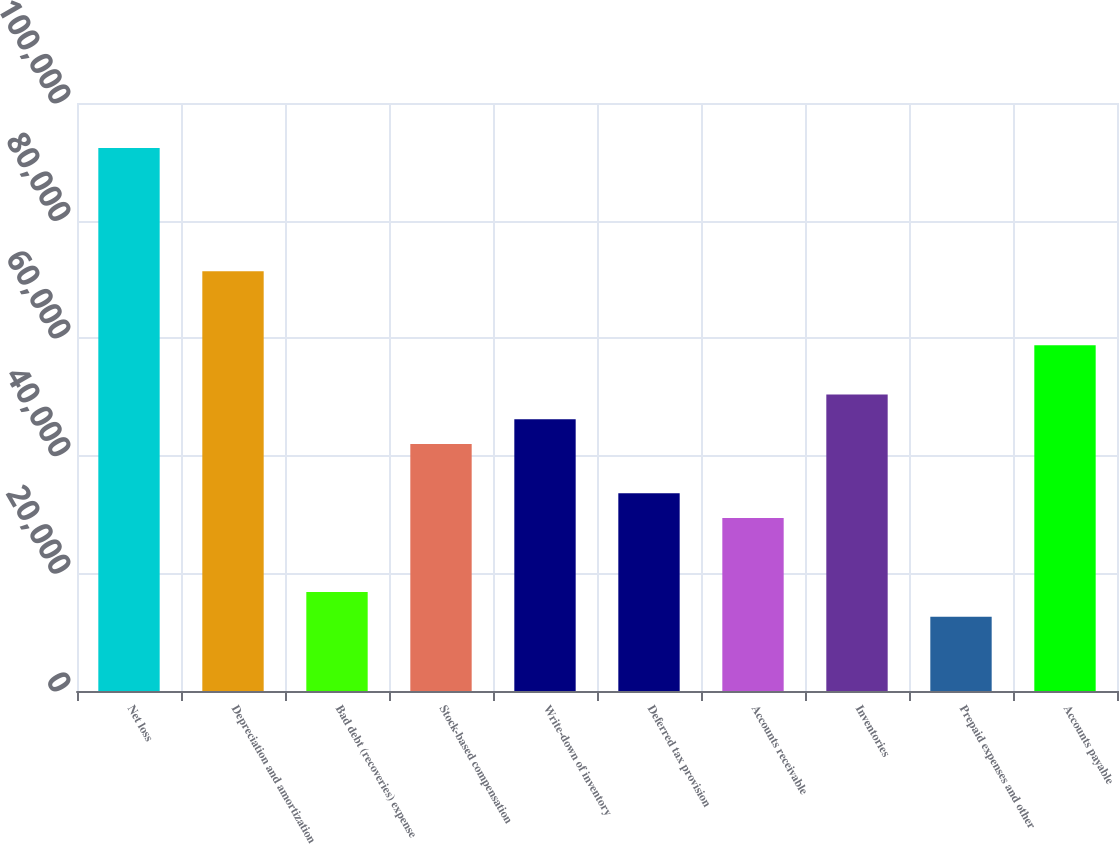<chart> <loc_0><loc_0><loc_500><loc_500><bar_chart><fcel>Net loss<fcel>Depreciation and amortization<fcel>Bad debt (recoveries) expense<fcel>Stock-based compensation<fcel>Write-down of inventory<fcel>Deferred tax provision<fcel>Accounts receivable<fcel>Inventories<fcel>Prepaid expenses and other<fcel>Accounts payable<nl><fcel>92364.4<fcel>71385.9<fcel>16841.8<fcel>42016<fcel>46211.7<fcel>33624.6<fcel>29428.9<fcel>50407.4<fcel>12646.1<fcel>58798.8<nl></chart> 